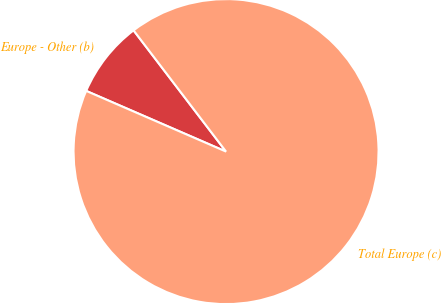Convert chart. <chart><loc_0><loc_0><loc_500><loc_500><pie_chart><fcel>Europe - Other (b)<fcel>Total Europe (c)<nl><fcel>8.11%<fcel>91.89%<nl></chart> 